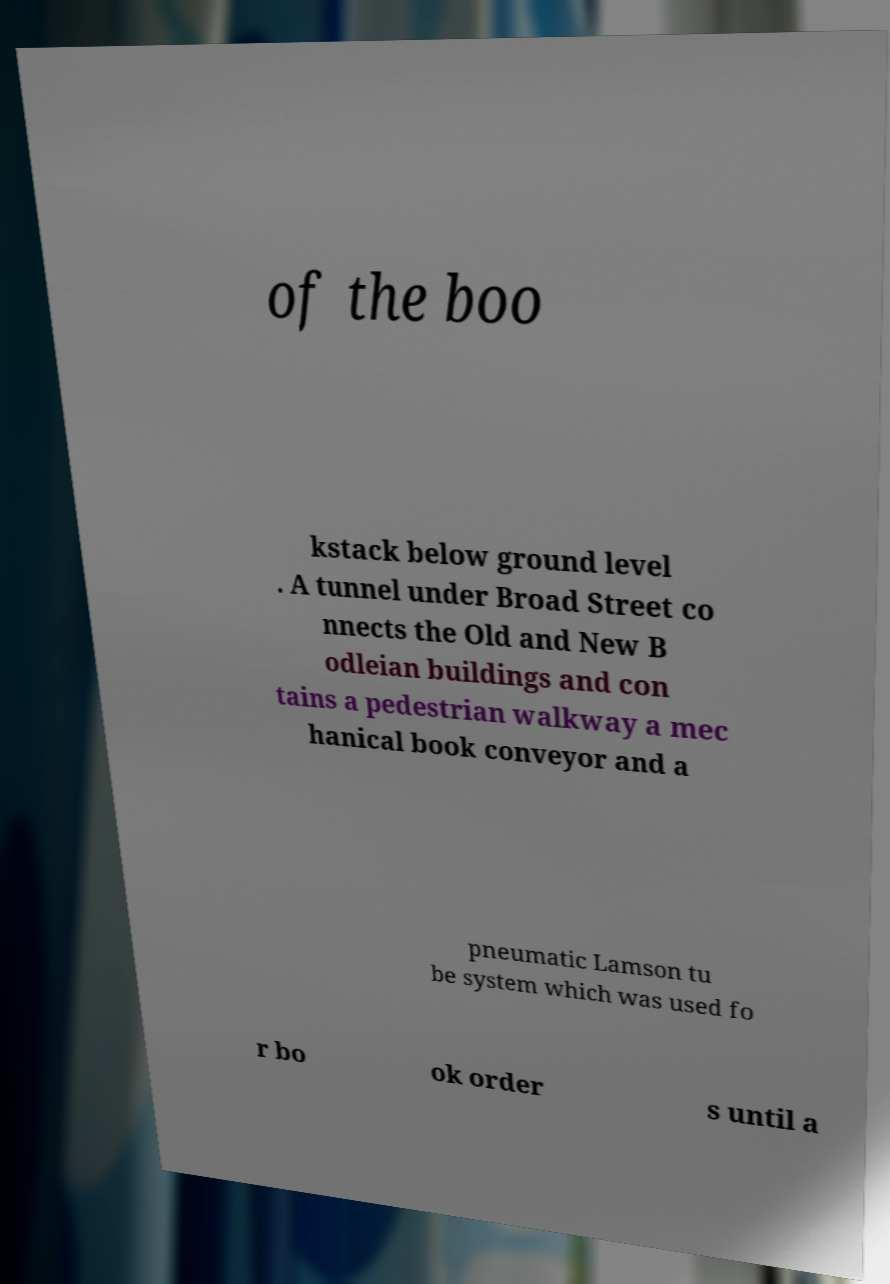Could you assist in decoding the text presented in this image and type it out clearly? of the boo kstack below ground level . A tunnel under Broad Street co nnects the Old and New B odleian buildings and con tains a pedestrian walkway a mec hanical book conveyor and a pneumatic Lamson tu be system which was used fo r bo ok order s until a 